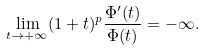Convert formula to latex. <formula><loc_0><loc_0><loc_500><loc_500>\lim _ { t \to + \infty } ( 1 + t ) ^ { p } \frac { \Phi ^ { \prime } ( t ) } { \Phi ( t ) } = - \infty .</formula> 